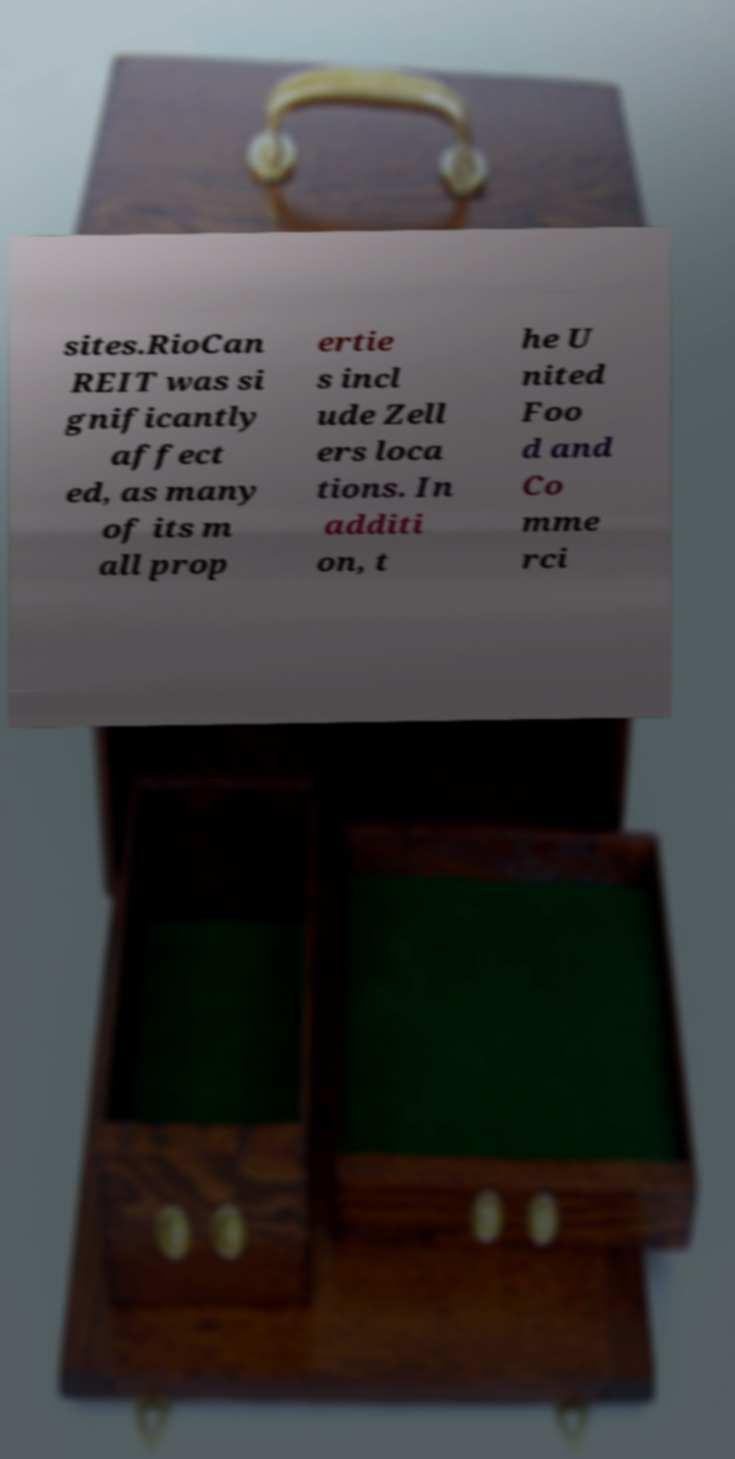For documentation purposes, I need the text within this image transcribed. Could you provide that? sites.RioCan REIT was si gnificantly affect ed, as many of its m all prop ertie s incl ude Zell ers loca tions. In additi on, t he U nited Foo d and Co mme rci 